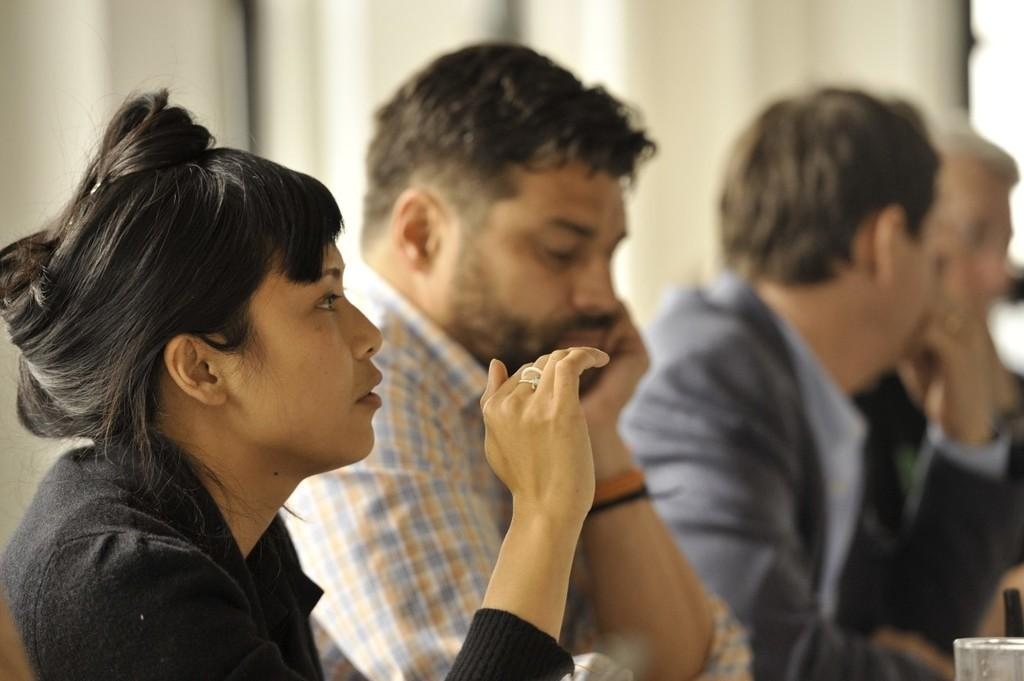What are the people in the image doing? The people in the image are sitting. Can you describe any objects in the image? There is a glass in the right side bottom corner of the image. What can be observed about the background of the image? The background of the image is blurred. What type of tools does the carpenter have in the image? There is no carpenter present in the image, so no tools can be observed. How many chairs are visible in the image? There is no mention of chairs in the provided facts, so it cannot be determined how many chairs are visible in the image. 